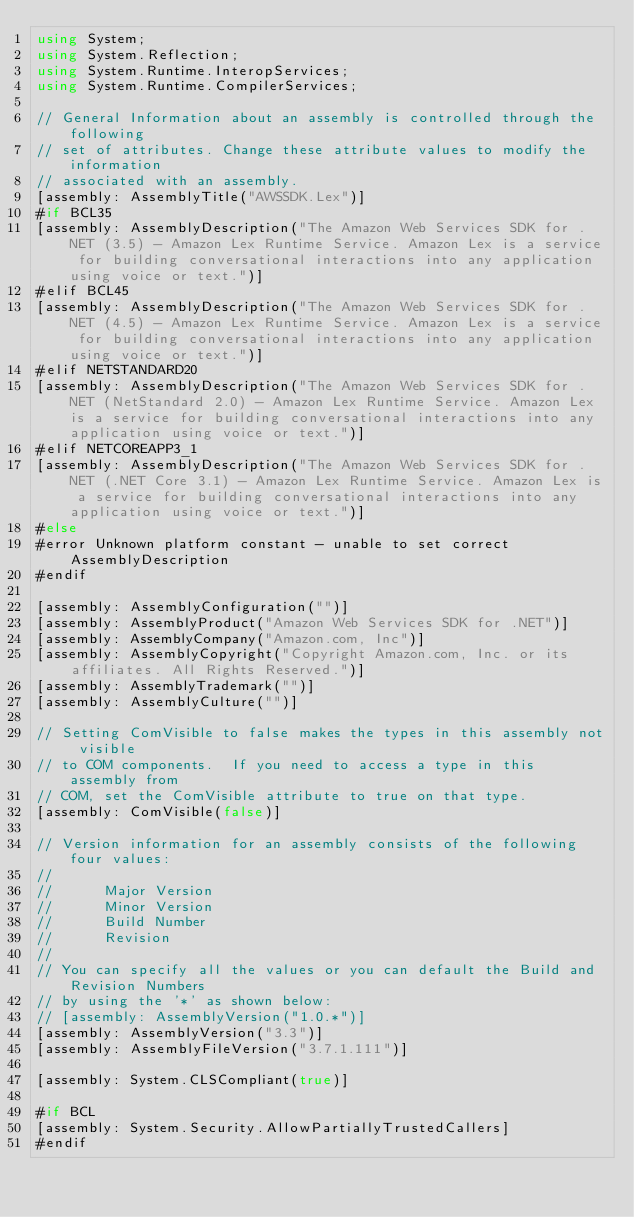<code> <loc_0><loc_0><loc_500><loc_500><_C#_>using System;
using System.Reflection;
using System.Runtime.InteropServices;
using System.Runtime.CompilerServices;

// General Information about an assembly is controlled through the following 
// set of attributes. Change these attribute values to modify the information
// associated with an assembly.
[assembly: AssemblyTitle("AWSSDK.Lex")]
#if BCL35
[assembly: AssemblyDescription("The Amazon Web Services SDK for .NET (3.5) - Amazon Lex Runtime Service. Amazon Lex is a service for building conversational interactions into any application using voice or text.")]
#elif BCL45
[assembly: AssemblyDescription("The Amazon Web Services SDK for .NET (4.5) - Amazon Lex Runtime Service. Amazon Lex is a service for building conversational interactions into any application using voice or text.")]
#elif NETSTANDARD20
[assembly: AssemblyDescription("The Amazon Web Services SDK for .NET (NetStandard 2.0) - Amazon Lex Runtime Service. Amazon Lex is a service for building conversational interactions into any application using voice or text.")]
#elif NETCOREAPP3_1
[assembly: AssemblyDescription("The Amazon Web Services SDK for .NET (.NET Core 3.1) - Amazon Lex Runtime Service. Amazon Lex is a service for building conversational interactions into any application using voice or text.")]
#else
#error Unknown platform constant - unable to set correct AssemblyDescription
#endif

[assembly: AssemblyConfiguration("")]
[assembly: AssemblyProduct("Amazon Web Services SDK for .NET")]
[assembly: AssemblyCompany("Amazon.com, Inc")]
[assembly: AssemblyCopyright("Copyright Amazon.com, Inc. or its affiliates. All Rights Reserved.")]
[assembly: AssemblyTrademark("")]
[assembly: AssemblyCulture("")]

// Setting ComVisible to false makes the types in this assembly not visible 
// to COM components.  If you need to access a type in this assembly from 
// COM, set the ComVisible attribute to true on that type.
[assembly: ComVisible(false)]

// Version information for an assembly consists of the following four values:
//
//      Major Version
//      Minor Version 
//      Build Number
//      Revision
//
// You can specify all the values or you can default the Build and Revision Numbers 
// by using the '*' as shown below:
// [assembly: AssemblyVersion("1.0.*")]
[assembly: AssemblyVersion("3.3")]
[assembly: AssemblyFileVersion("3.7.1.111")]

[assembly: System.CLSCompliant(true)]

#if BCL
[assembly: System.Security.AllowPartiallyTrustedCallers]
#endif</code> 